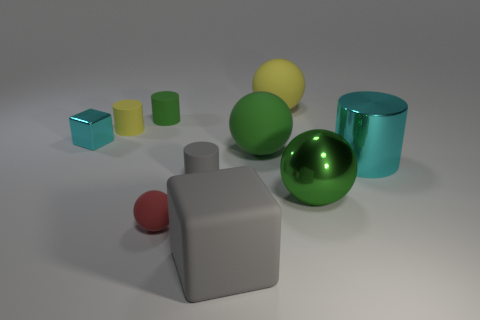There is a large green sphere behind the cyan shiny thing that is to the right of the large gray rubber thing; are there any green rubber balls that are to the right of it?
Keep it short and to the point. No. There is a small yellow thing; what number of green objects are in front of it?
Offer a terse response. 2. There is a large cylinder that is the same color as the tiny metal thing; what is it made of?
Keep it short and to the point. Metal. How many big things are red spheres or cylinders?
Your answer should be very brief. 1. The tiny yellow matte object that is behind the big metallic cylinder has what shape?
Provide a short and direct response. Cylinder. Are there any small cubes that have the same color as the shiny cylinder?
Offer a terse response. Yes. Is the size of the sphere that is in front of the shiny sphere the same as the cyan metallic object that is to the left of the gray rubber cylinder?
Make the answer very short. Yes. Are there more large green balls that are on the right side of the matte block than big cyan shiny cylinders that are behind the small yellow thing?
Provide a succinct answer. Yes. Is there a tiny cyan block that has the same material as the cyan cylinder?
Give a very brief answer. Yes. Do the big cylinder and the metallic block have the same color?
Keep it short and to the point. Yes. 